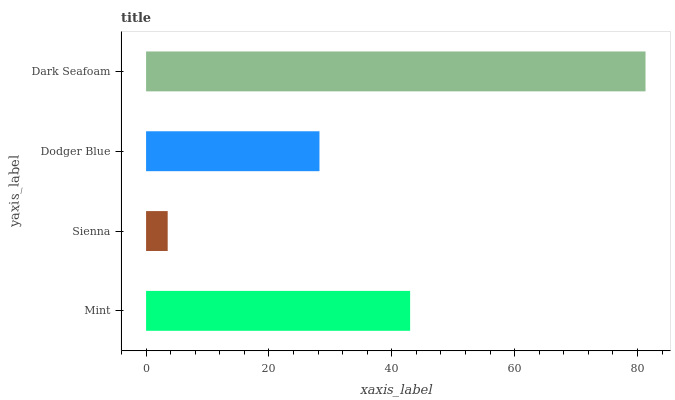Is Sienna the minimum?
Answer yes or no. Yes. Is Dark Seafoam the maximum?
Answer yes or no. Yes. Is Dodger Blue the minimum?
Answer yes or no. No. Is Dodger Blue the maximum?
Answer yes or no. No. Is Dodger Blue greater than Sienna?
Answer yes or no. Yes. Is Sienna less than Dodger Blue?
Answer yes or no. Yes. Is Sienna greater than Dodger Blue?
Answer yes or no. No. Is Dodger Blue less than Sienna?
Answer yes or no. No. Is Mint the high median?
Answer yes or no. Yes. Is Dodger Blue the low median?
Answer yes or no. Yes. Is Dark Seafoam the high median?
Answer yes or no. No. Is Mint the low median?
Answer yes or no. No. 